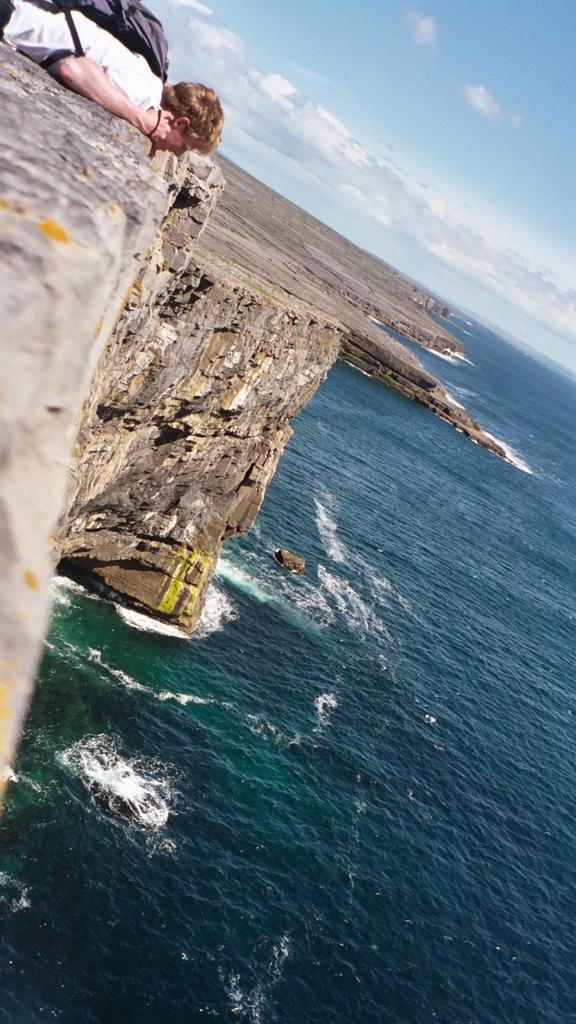What is the main subject of the image? There is a person in the image. What is the person wearing? The person is wearing a bag. What is the person's position in the image? The person is lying down. What type of natural elements can be seen in the image? Rocks and water are visible in the image. What is visible in the background of the image? The sky is visible in the background of the image. What can be observed in the sky? Clouds are present in the sky. What type of jeans is the person wearing in the image? There is no mention of jeans in the image; the person is wearing a bag. How does the stove affect the person's position in the image? There is no stove present in the image, so it cannot affect the person's position. 